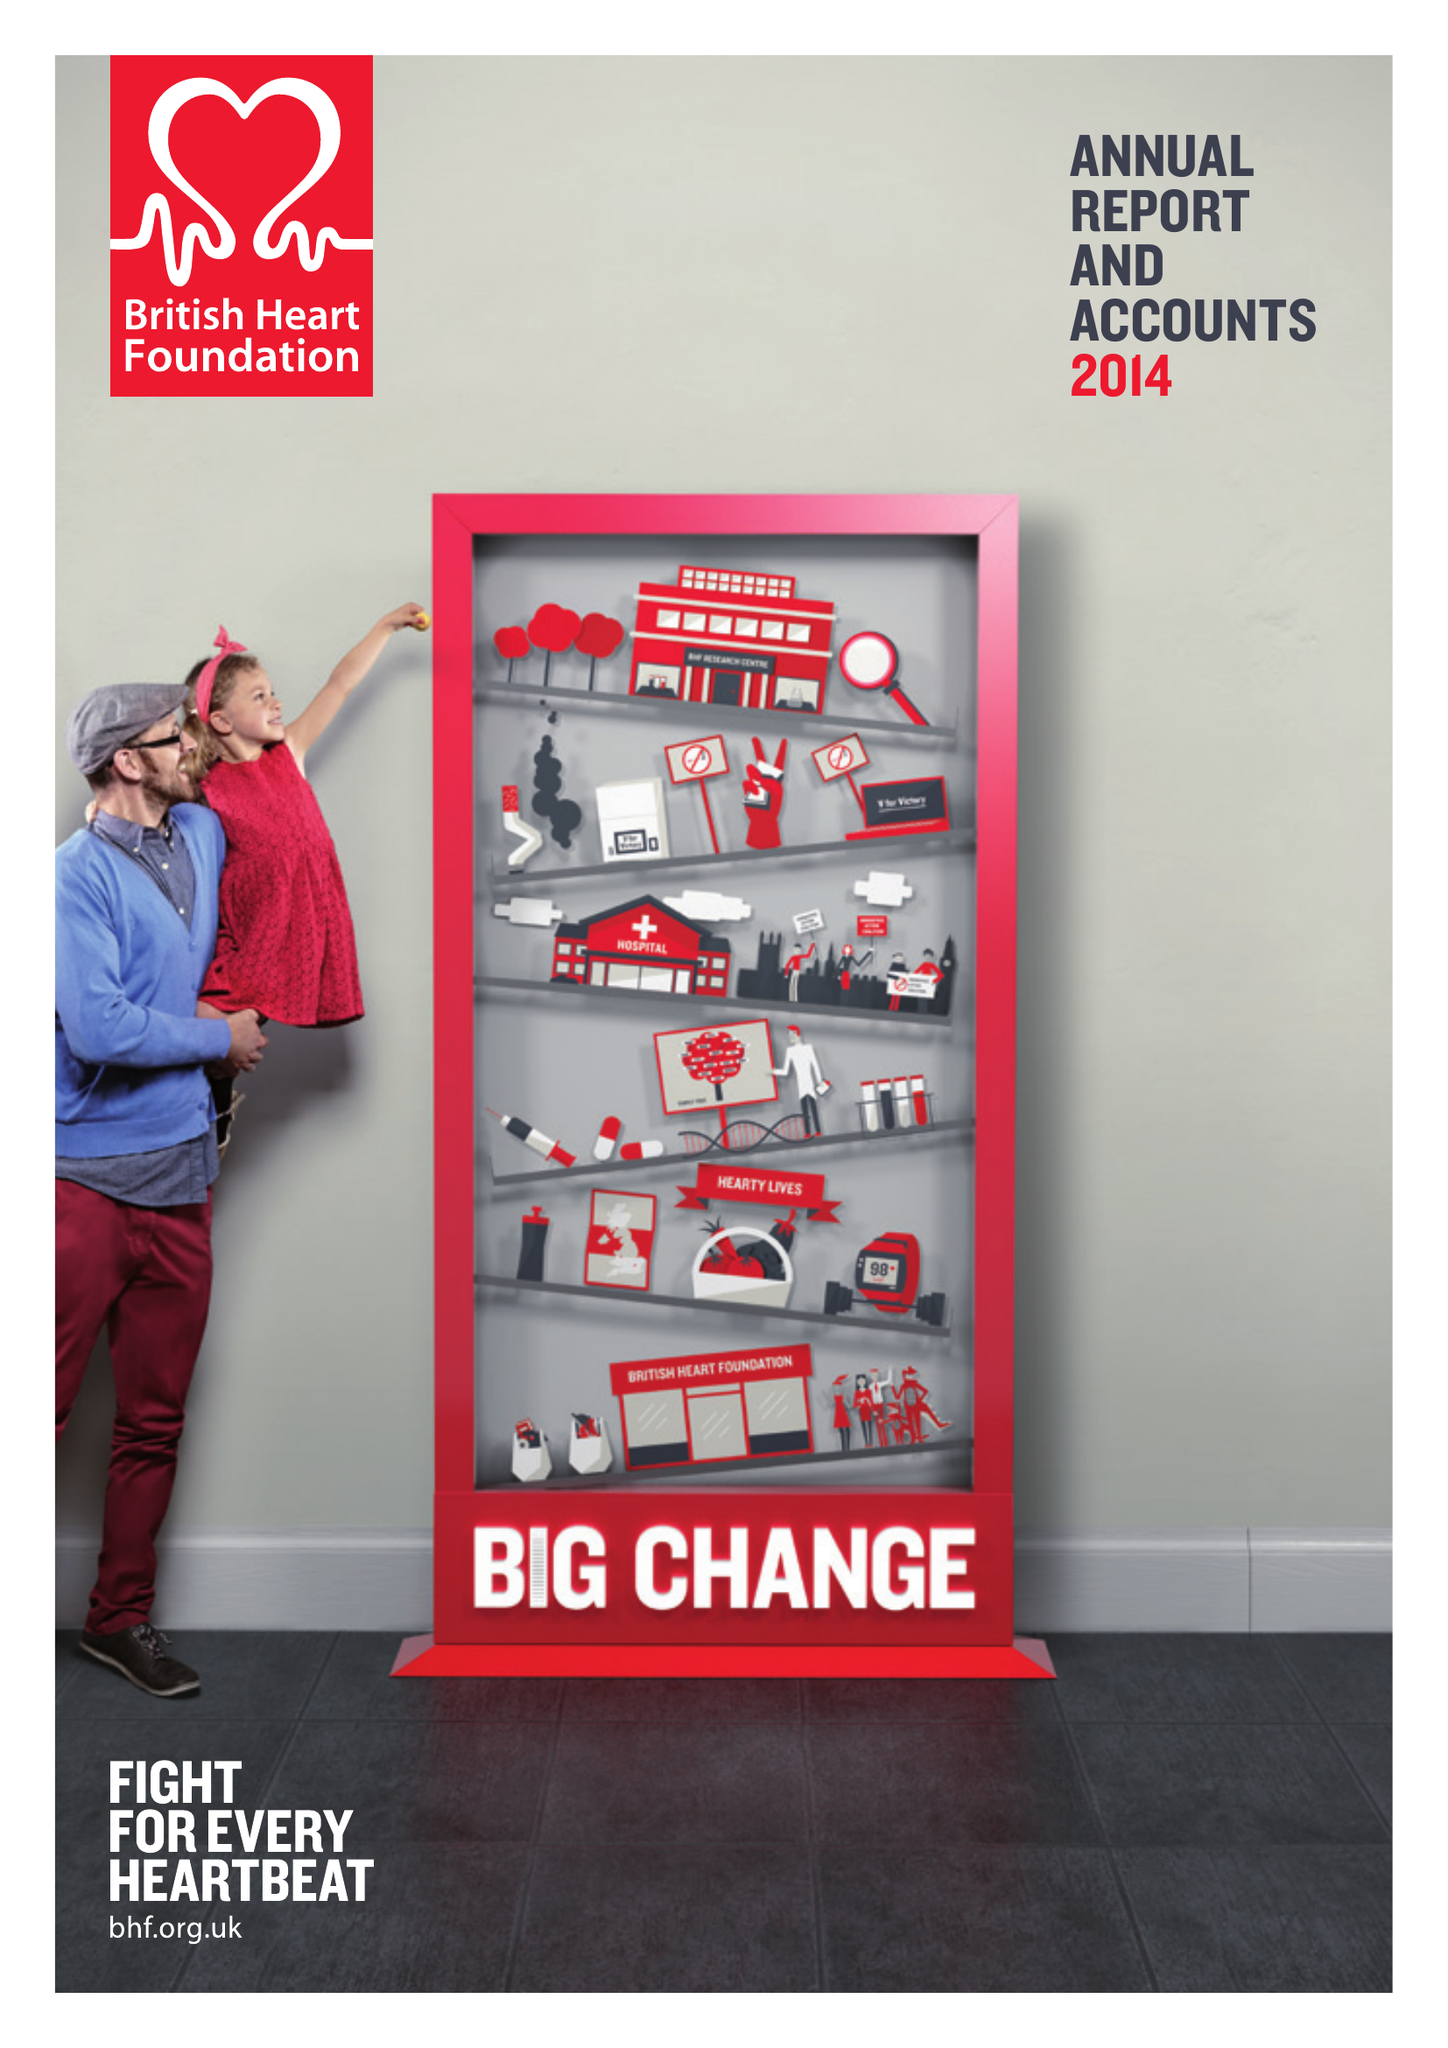What is the value for the report_date?
Answer the question using a single word or phrase. 2014-03-31 